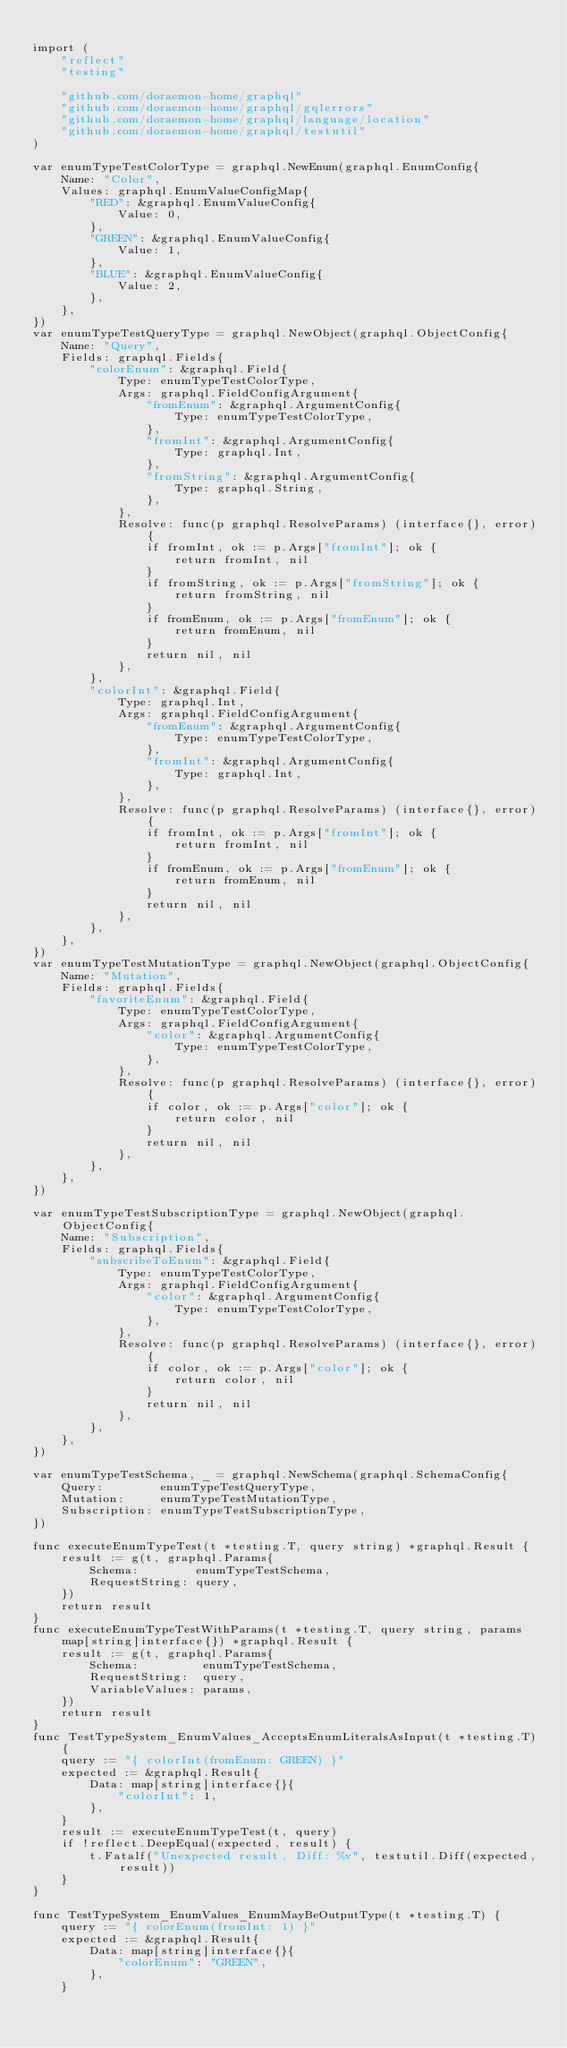<code> <loc_0><loc_0><loc_500><loc_500><_Go_>
import (
	"reflect"
	"testing"

	"github.com/doraemon-home/graphql"
	"github.com/doraemon-home/graphql/gqlerrors"
	"github.com/doraemon-home/graphql/language/location"
	"github.com/doraemon-home/graphql/testutil"
)

var enumTypeTestColorType = graphql.NewEnum(graphql.EnumConfig{
	Name: "Color",
	Values: graphql.EnumValueConfigMap{
		"RED": &graphql.EnumValueConfig{
			Value: 0,
		},
		"GREEN": &graphql.EnumValueConfig{
			Value: 1,
		},
		"BLUE": &graphql.EnumValueConfig{
			Value: 2,
		},
	},
})
var enumTypeTestQueryType = graphql.NewObject(graphql.ObjectConfig{
	Name: "Query",
	Fields: graphql.Fields{
		"colorEnum": &graphql.Field{
			Type: enumTypeTestColorType,
			Args: graphql.FieldConfigArgument{
				"fromEnum": &graphql.ArgumentConfig{
					Type: enumTypeTestColorType,
				},
				"fromInt": &graphql.ArgumentConfig{
					Type: graphql.Int,
				},
				"fromString": &graphql.ArgumentConfig{
					Type: graphql.String,
				},
			},
			Resolve: func(p graphql.ResolveParams) (interface{}, error) {
				if fromInt, ok := p.Args["fromInt"]; ok {
					return fromInt, nil
				}
				if fromString, ok := p.Args["fromString"]; ok {
					return fromString, nil
				}
				if fromEnum, ok := p.Args["fromEnum"]; ok {
					return fromEnum, nil
				}
				return nil, nil
			},
		},
		"colorInt": &graphql.Field{
			Type: graphql.Int,
			Args: graphql.FieldConfigArgument{
				"fromEnum": &graphql.ArgumentConfig{
					Type: enumTypeTestColorType,
				},
				"fromInt": &graphql.ArgumentConfig{
					Type: graphql.Int,
				},
			},
			Resolve: func(p graphql.ResolveParams) (interface{}, error) {
				if fromInt, ok := p.Args["fromInt"]; ok {
					return fromInt, nil
				}
				if fromEnum, ok := p.Args["fromEnum"]; ok {
					return fromEnum, nil
				}
				return nil, nil
			},
		},
	},
})
var enumTypeTestMutationType = graphql.NewObject(graphql.ObjectConfig{
	Name: "Mutation",
	Fields: graphql.Fields{
		"favoriteEnum": &graphql.Field{
			Type: enumTypeTestColorType,
			Args: graphql.FieldConfigArgument{
				"color": &graphql.ArgumentConfig{
					Type: enumTypeTestColorType,
				},
			},
			Resolve: func(p graphql.ResolveParams) (interface{}, error) {
				if color, ok := p.Args["color"]; ok {
					return color, nil
				}
				return nil, nil
			},
		},
	},
})

var enumTypeTestSubscriptionType = graphql.NewObject(graphql.ObjectConfig{
	Name: "Subscription",
	Fields: graphql.Fields{
		"subscribeToEnum": &graphql.Field{
			Type: enumTypeTestColorType,
			Args: graphql.FieldConfigArgument{
				"color": &graphql.ArgumentConfig{
					Type: enumTypeTestColorType,
				},
			},
			Resolve: func(p graphql.ResolveParams) (interface{}, error) {
				if color, ok := p.Args["color"]; ok {
					return color, nil
				}
				return nil, nil
			},
		},
	},
})

var enumTypeTestSchema, _ = graphql.NewSchema(graphql.SchemaConfig{
	Query:        enumTypeTestQueryType,
	Mutation:     enumTypeTestMutationType,
	Subscription: enumTypeTestSubscriptionType,
})

func executeEnumTypeTest(t *testing.T, query string) *graphql.Result {
	result := g(t, graphql.Params{
		Schema:        enumTypeTestSchema,
		RequestString: query,
	})
	return result
}
func executeEnumTypeTestWithParams(t *testing.T, query string, params map[string]interface{}) *graphql.Result {
	result := g(t, graphql.Params{
		Schema:         enumTypeTestSchema,
		RequestString:  query,
		VariableValues: params,
	})
	return result
}
func TestTypeSystem_EnumValues_AcceptsEnumLiteralsAsInput(t *testing.T) {
	query := "{ colorInt(fromEnum: GREEN) }"
	expected := &graphql.Result{
		Data: map[string]interface{}{
			"colorInt": 1,
		},
	}
	result := executeEnumTypeTest(t, query)
	if !reflect.DeepEqual(expected, result) {
		t.Fatalf("Unexpected result, Diff: %v", testutil.Diff(expected, result))
	}
}

func TestTypeSystem_EnumValues_EnumMayBeOutputType(t *testing.T) {
	query := "{ colorEnum(fromInt: 1) }"
	expected := &graphql.Result{
		Data: map[string]interface{}{
			"colorEnum": "GREEN",
		},
	}</code> 